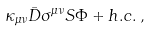<formula> <loc_0><loc_0><loc_500><loc_500>\kappa _ { \mu \nu } \bar { D } \sigma ^ { \mu \nu } S \Phi + h . c . \, ,</formula> 